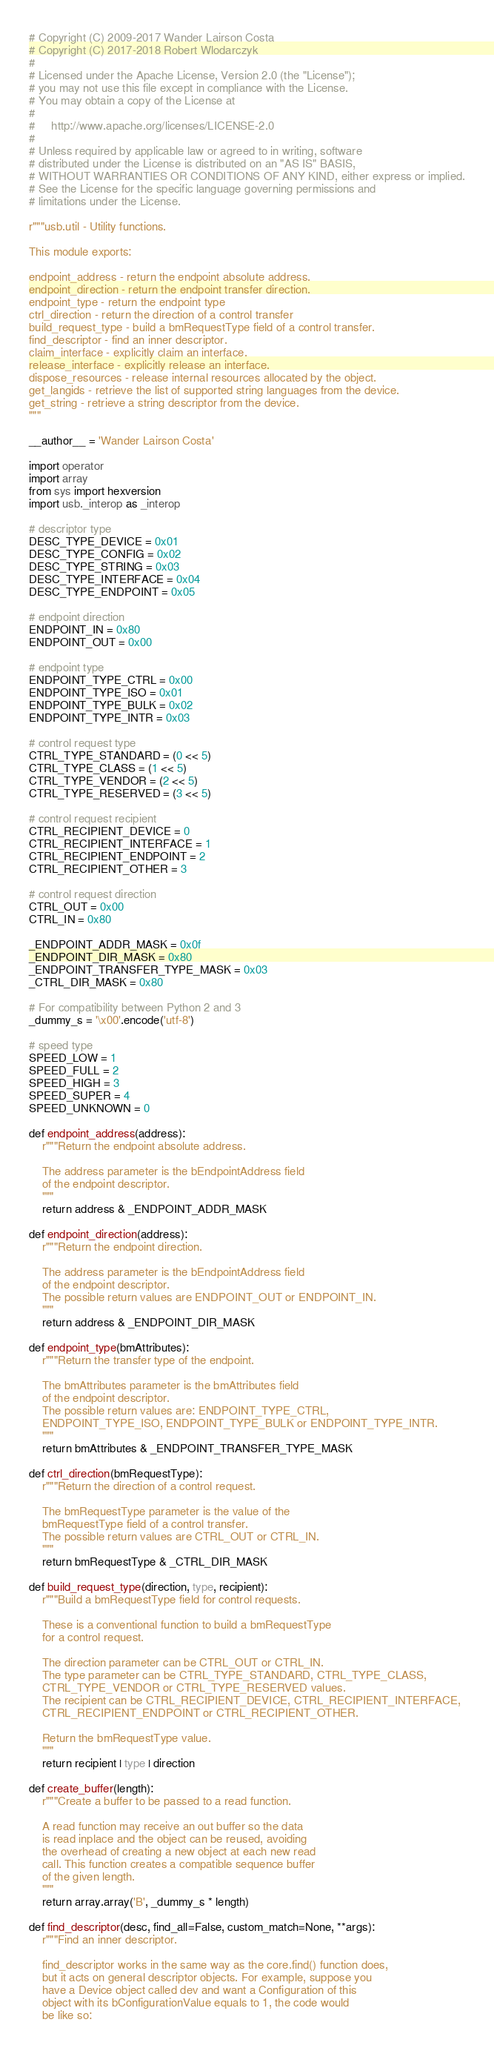Convert code to text. <code><loc_0><loc_0><loc_500><loc_500><_Python_># Copyright (C) 2009-2017 Wander Lairson Costa
# Copyright (C) 2017-2018 Robert Wlodarczyk
#
# Licensed under the Apache License, Version 2.0 (the "License");
# you may not use this file except in compliance with the License.
# You may obtain a copy of the License at
#
#     http://www.apache.org/licenses/LICENSE-2.0
#
# Unless required by applicable law or agreed to in writing, software
# distributed under the License is distributed on an "AS IS" BASIS,
# WITHOUT WARRANTIES OR CONDITIONS OF ANY KIND, either express or implied.
# See the License for the specific language governing permissions and
# limitations under the License.

r"""usb.util - Utility functions.

This module exports:

endpoint_address - return the endpoint absolute address.
endpoint_direction - return the endpoint transfer direction.
endpoint_type - return the endpoint type
ctrl_direction - return the direction of a control transfer
build_request_type - build a bmRequestType field of a control transfer.
find_descriptor - find an inner descriptor.
claim_interface - explicitly claim an interface.
release_interface - explicitly release an interface.
dispose_resources - release internal resources allocated by the object.
get_langids - retrieve the list of supported string languages from the device.
get_string - retrieve a string descriptor from the device.
"""

__author__ = 'Wander Lairson Costa'

import operator
import array
from sys import hexversion
import usb._interop as _interop

# descriptor type
DESC_TYPE_DEVICE = 0x01
DESC_TYPE_CONFIG = 0x02
DESC_TYPE_STRING = 0x03
DESC_TYPE_INTERFACE = 0x04
DESC_TYPE_ENDPOINT = 0x05

# endpoint direction
ENDPOINT_IN = 0x80
ENDPOINT_OUT = 0x00

# endpoint type
ENDPOINT_TYPE_CTRL = 0x00
ENDPOINT_TYPE_ISO = 0x01
ENDPOINT_TYPE_BULK = 0x02
ENDPOINT_TYPE_INTR = 0x03

# control request type
CTRL_TYPE_STANDARD = (0 << 5)
CTRL_TYPE_CLASS = (1 << 5)
CTRL_TYPE_VENDOR = (2 << 5)
CTRL_TYPE_RESERVED = (3 << 5)

# control request recipient
CTRL_RECIPIENT_DEVICE = 0
CTRL_RECIPIENT_INTERFACE = 1
CTRL_RECIPIENT_ENDPOINT = 2
CTRL_RECIPIENT_OTHER = 3

# control request direction
CTRL_OUT = 0x00
CTRL_IN = 0x80

_ENDPOINT_ADDR_MASK = 0x0f
_ENDPOINT_DIR_MASK = 0x80
_ENDPOINT_TRANSFER_TYPE_MASK = 0x03
_CTRL_DIR_MASK = 0x80

# For compatibility between Python 2 and 3
_dummy_s = '\x00'.encode('utf-8')

# speed type
SPEED_LOW = 1
SPEED_FULL = 2
SPEED_HIGH = 3
SPEED_SUPER = 4
SPEED_UNKNOWN = 0

def endpoint_address(address):
    r"""Return the endpoint absolute address.

    The address parameter is the bEndpointAddress field
    of the endpoint descriptor.
    """
    return address & _ENDPOINT_ADDR_MASK

def endpoint_direction(address):
    r"""Return the endpoint direction.

    The address parameter is the bEndpointAddress field
    of the endpoint descriptor.
    The possible return values are ENDPOINT_OUT or ENDPOINT_IN.
    """
    return address & _ENDPOINT_DIR_MASK

def endpoint_type(bmAttributes):
    r"""Return the transfer type of the endpoint.

    The bmAttributes parameter is the bmAttributes field
    of the endpoint descriptor.
    The possible return values are: ENDPOINT_TYPE_CTRL,
    ENDPOINT_TYPE_ISO, ENDPOINT_TYPE_BULK or ENDPOINT_TYPE_INTR.
    """
    return bmAttributes & _ENDPOINT_TRANSFER_TYPE_MASK

def ctrl_direction(bmRequestType):
    r"""Return the direction of a control request.

    The bmRequestType parameter is the value of the
    bmRequestType field of a control transfer.
    The possible return values are CTRL_OUT or CTRL_IN.
    """
    return bmRequestType & _CTRL_DIR_MASK

def build_request_type(direction, type, recipient):
    r"""Build a bmRequestType field for control requests.

    These is a conventional function to build a bmRequestType
    for a control request.

    The direction parameter can be CTRL_OUT or CTRL_IN.
    The type parameter can be CTRL_TYPE_STANDARD, CTRL_TYPE_CLASS,
    CTRL_TYPE_VENDOR or CTRL_TYPE_RESERVED values.
    The recipient can be CTRL_RECIPIENT_DEVICE, CTRL_RECIPIENT_INTERFACE,
    CTRL_RECIPIENT_ENDPOINT or CTRL_RECIPIENT_OTHER.

    Return the bmRequestType value.
    """
    return recipient | type | direction

def create_buffer(length):
    r"""Create a buffer to be passed to a read function.

    A read function may receive an out buffer so the data
    is read inplace and the object can be reused, avoiding
    the overhead of creating a new object at each new read
    call. This function creates a compatible sequence buffer
    of the given length.
    """
    return array.array('B', _dummy_s * length)

def find_descriptor(desc, find_all=False, custom_match=None, **args):
    r"""Find an inner descriptor.

    find_descriptor works in the same way as the core.find() function does,
    but it acts on general descriptor objects. For example, suppose you
    have a Device object called dev and want a Configuration of this
    object with its bConfigurationValue equals to 1, the code would
    be like so:
</code> 